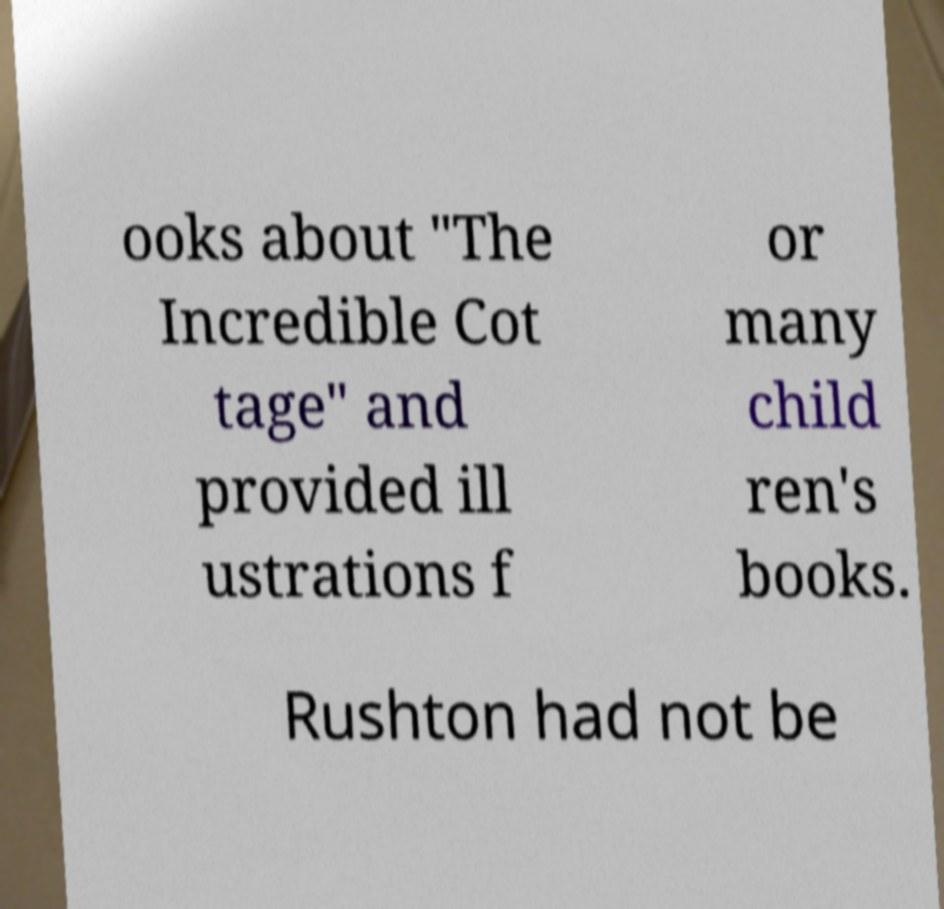Could you extract and type out the text from this image? ooks about "The Incredible Cot tage" and provided ill ustrations f or many child ren's books. Rushton had not be 